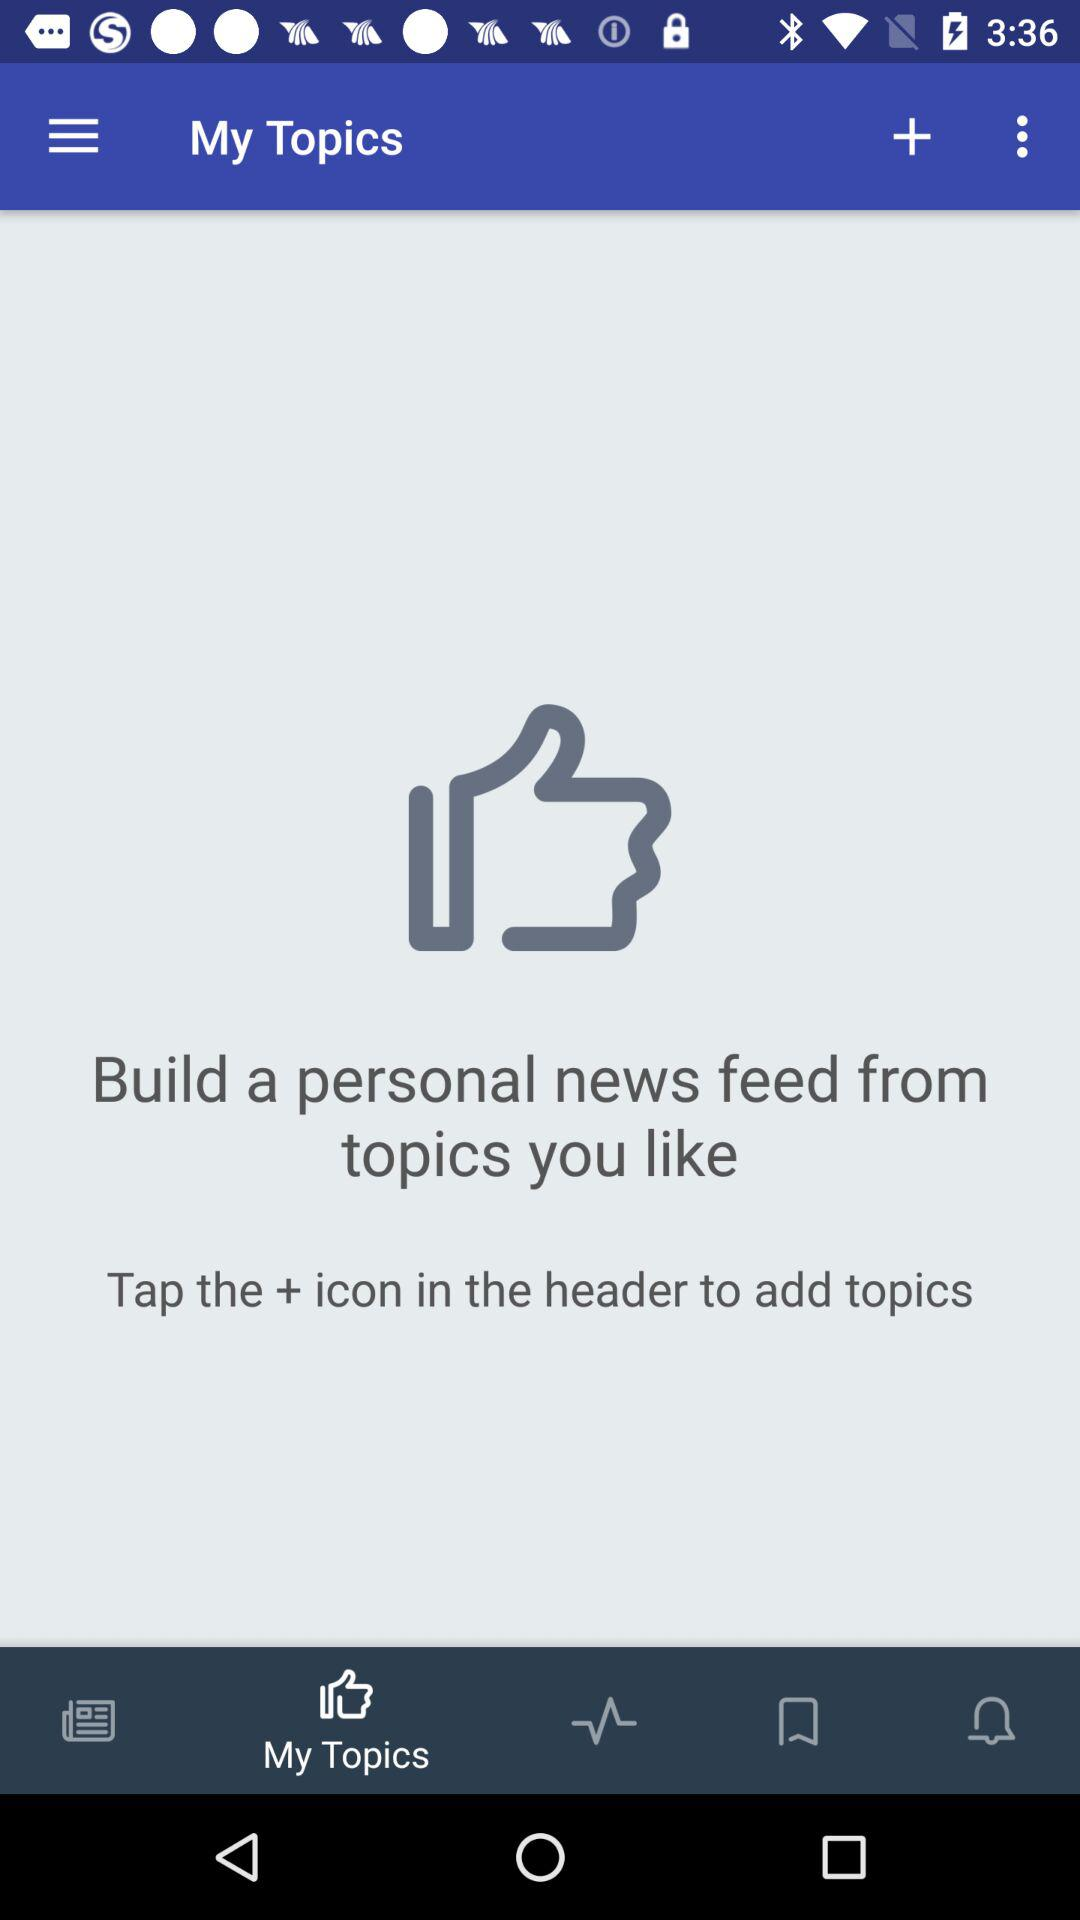Which tab is selected? The selected tab is "My Topics". 